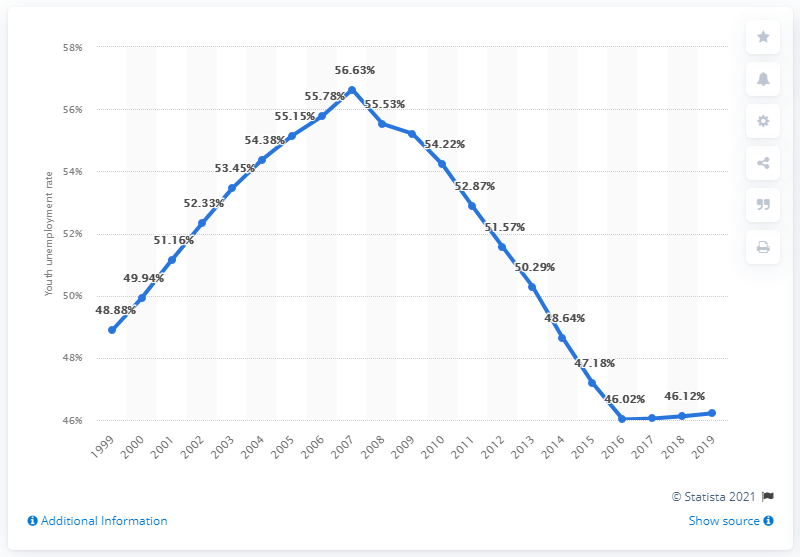Point out several critical features in this image. The youth unemployment rate in Swaziland in 2019 was 46.22%. 